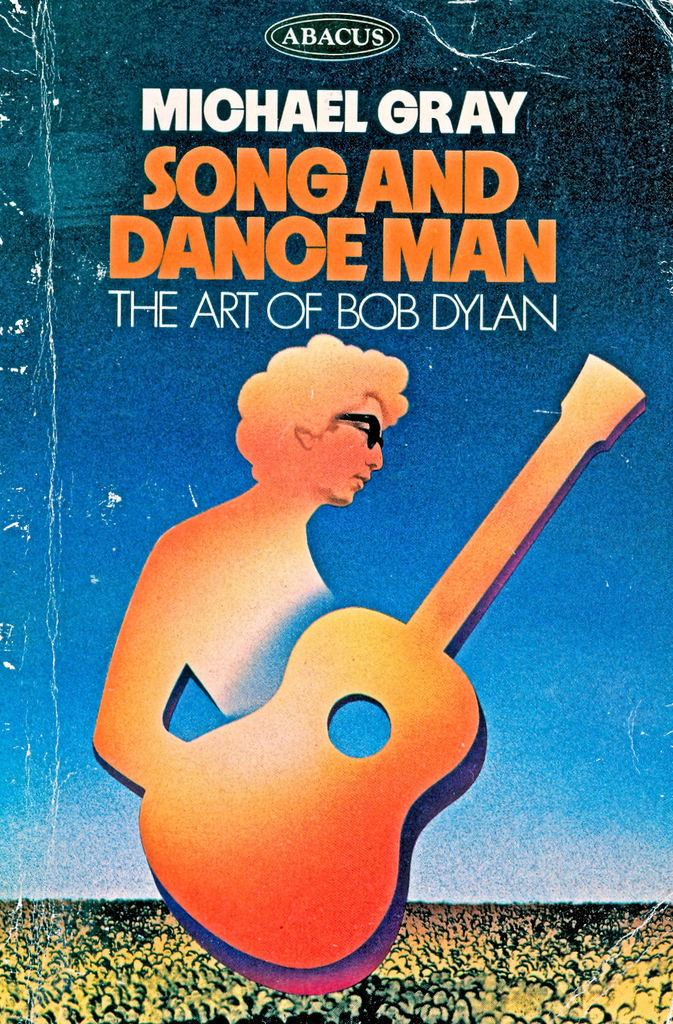Provide a one-sentence caption for the provided image. Cover of Bob Dylan booklet showing a man holding an orange guitar on the cover. 